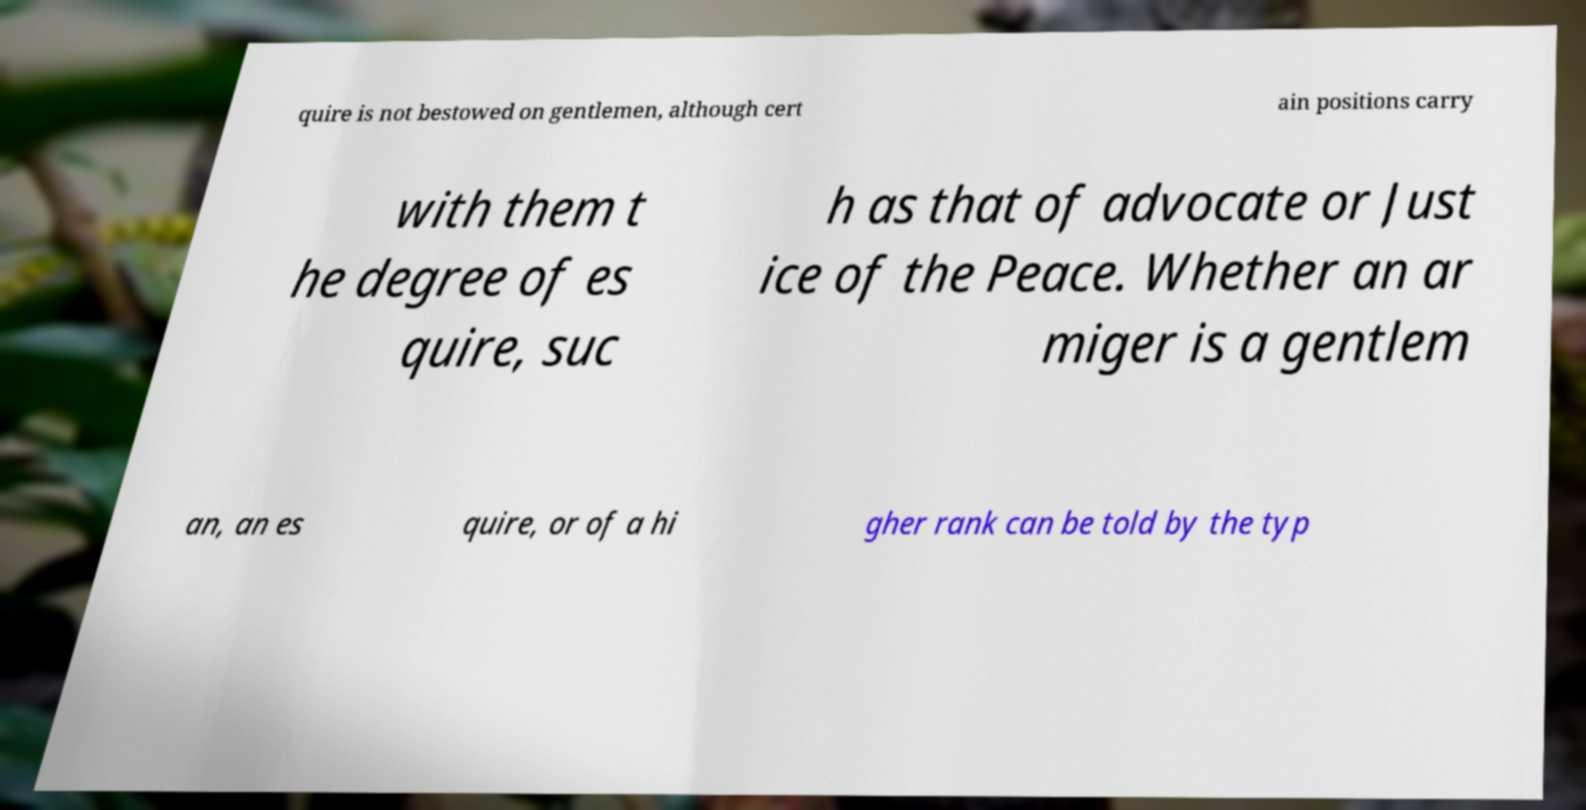There's text embedded in this image that I need extracted. Can you transcribe it verbatim? quire is not bestowed on gentlemen, although cert ain positions carry with them t he degree of es quire, suc h as that of advocate or Just ice of the Peace. Whether an ar miger is a gentlem an, an es quire, or of a hi gher rank can be told by the typ 